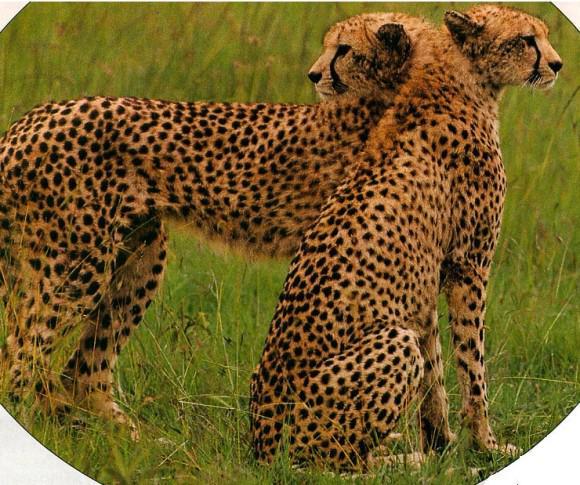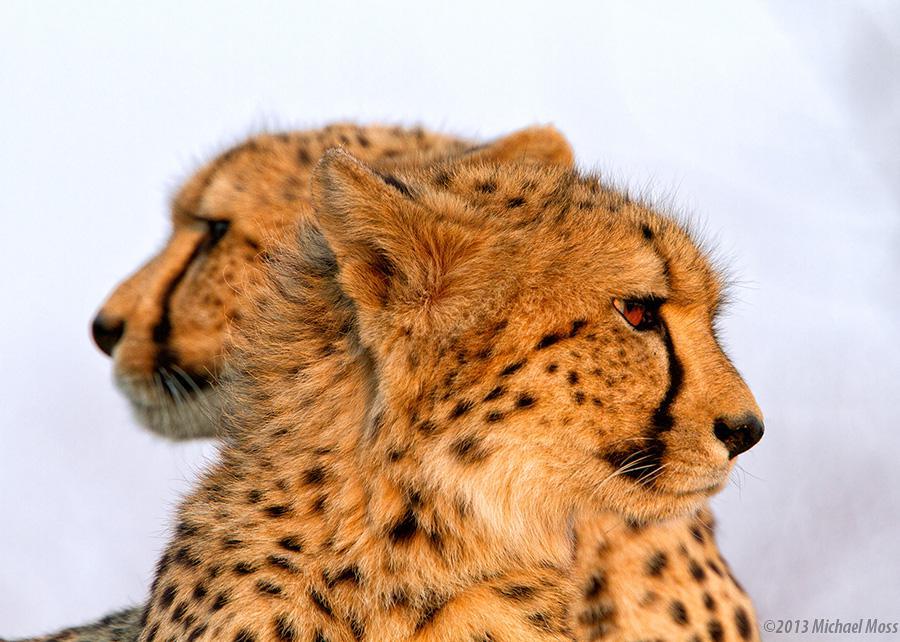The first image is the image on the left, the second image is the image on the right. Given the left and right images, does the statement "Each image shows exactly one pair of wild spotted cts with their heads overlapping." hold true? Answer yes or no. Yes. 